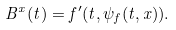Convert formula to latex. <formula><loc_0><loc_0><loc_500><loc_500>B ^ { x } ( t ) = f ^ { \prime } ( t , \psi _ { f } ( t , x ) ) .</formula> 